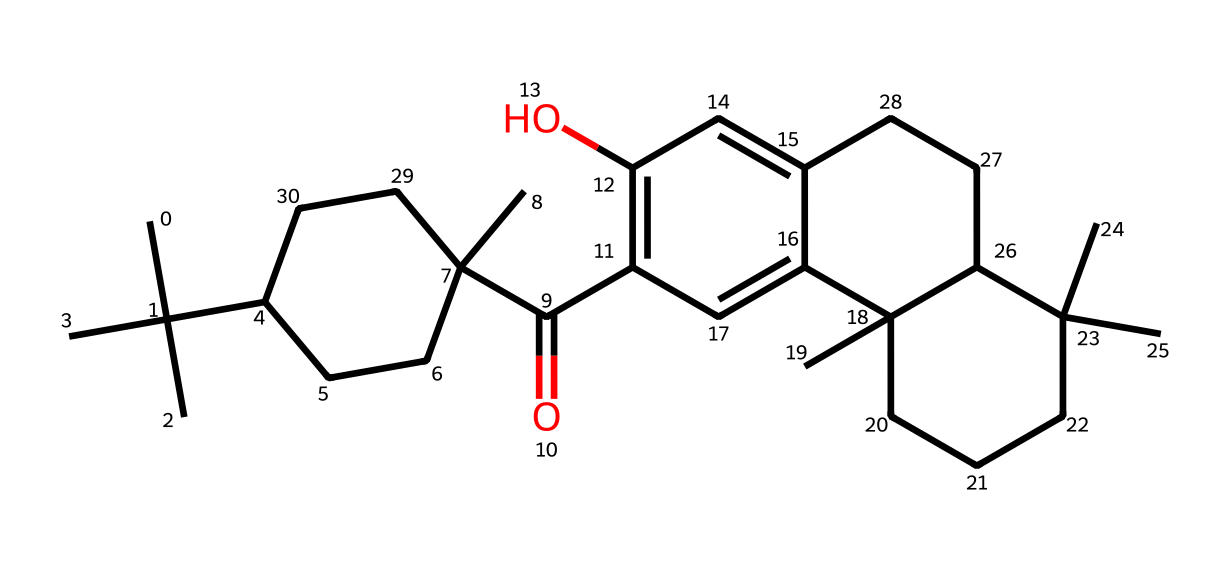What is the molecular formula of THC? To determine the molecular formula, we need to count the number of each type of atom present in the chemical structure represented by the SMILES. For this SMILES, we identify 21 carbon atoms, 30 hydrogen atoms, and 2 oxygen atoms, leading to the formula C21H30O2.
Answer: C21H30O2 How many rings are present in the structure? Analyzing the SMILES representation, we observe multiple ring structures indicated by the numerical indicators (e.g., "C1", "C2", "C3"). By tracing these numbers, we find that there are three distinct ring systems in the overall structure.
Answer: 3 Does this compound contain any oxygen atoms? We can see from the SMILES representation that the letters "O" appear twice, indicating the presence of oxygen atoms.
Answer: Yes What type of functional groups are present in THC? In the provided SMILES, we identify a ketone group (C=O) and a hydroxyl group (—OH). The presence of these groups suggests the chemical's reactivity and properties.
Answer: Ketone and hydroxyl Is THC an aromatic compound? An aromatic compound typically contains a conjugated system of pi electrons in a cyclic structure. The presence of alternating double bonds in the rings can indicate aromaticity. In THC, the ring systems and conjugated double bonds confirm it is aromatic.
Answer: Yes How does the structure of THC impact drug policy? The complex structure of THC, with its specific functional groups and rings, leads to its psychoactive effects, influencing debates in drug policy regarding legality and medical use.
Answer: Psychoactive effects What social norms influence perceptions of THC? Social norms related to drug consumption, legality, and the stigma surrounding cannabis affect how THC is perceived and utilized in society, impacting its acceptance and regulation.
Answer: Stigma and legality 